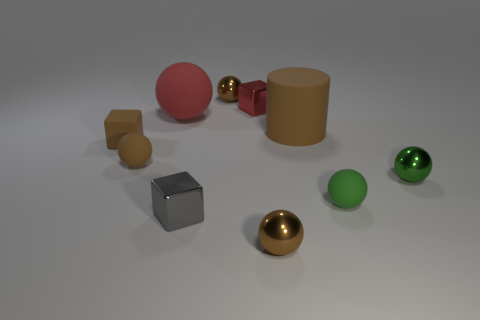Subtract all small shiny cubes. How many cubes are left? 1 Subtract all brown cubes. How many brown spheres are left? 3 Subtract 1 cubes. How many cubes are left? 2 Subtract all blocks. How many objects are left? 7 Subtract all brown spheres. How many spheres are left? 3 Subtract all purple balls. Subtract all cyan cubes. How many balls are left? 6 Subtract 1 green balls. How many objects are left? 9 Subtract all small green objects. Subtract all tiny cyan objects. How many objects are left? 8 Add 7 brown matte spheres. How many brown matte spheres are left? 8 Add 9 red metal cubes. How many red metal cubes exist? 10 